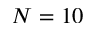Convert formula to latex. <formula><loc_0><loc_0><loc_500><loc_500>N = 1 0</formula> 